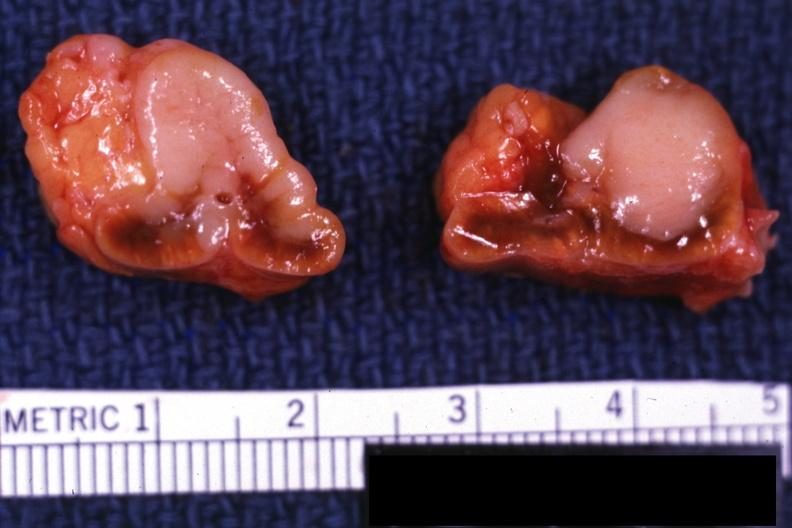does this image show sectioned gland bilateral lesions excellent example?
Answer the question using a single word or phrase. Yes 